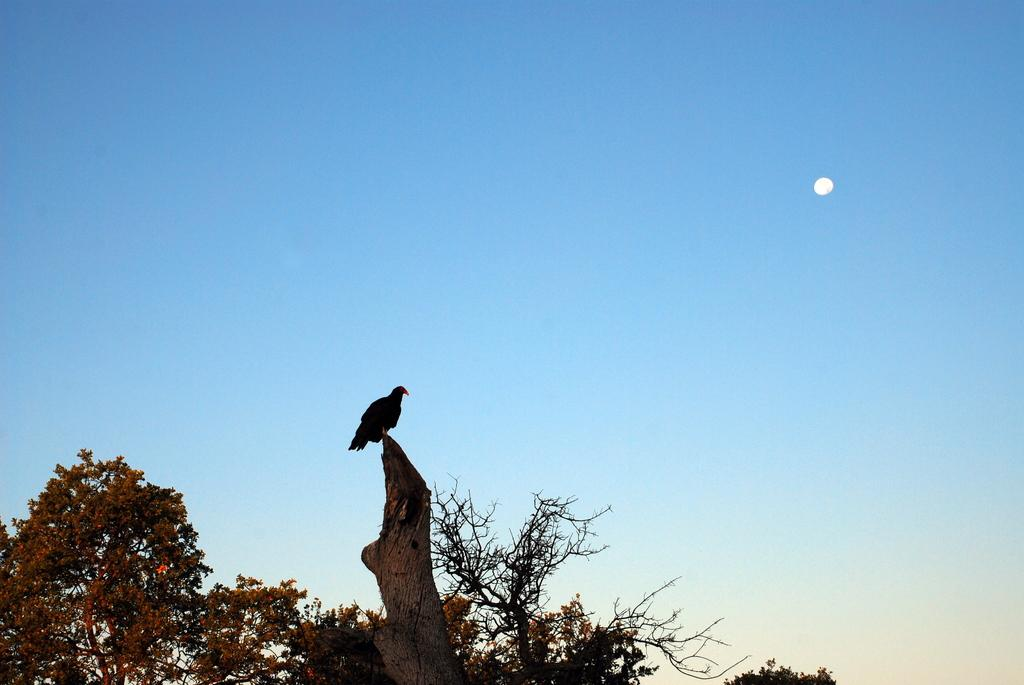What is on the tree trunk in the image? There is a bird on a tree trunk in the image. What type of vegetation is visible in the image? There are trees visible in the image. What is the color of the sky in the image? The sky is blue in color. What celestial body is visible in the sky? The moon is visible in the sky. What type of apples are hanging from the tree in the image? There are no apples present in the image; it features a bird on a tree trunk and trees in the background. What type of tank can be seen in the image? There is no tank present in the image. 